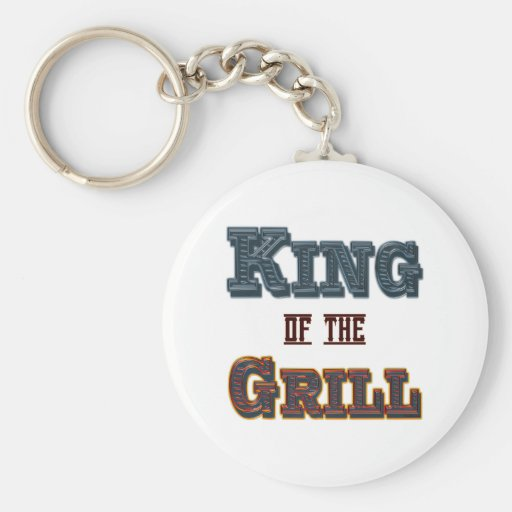Based on the design elements and color choices used in the text on the keychain, what type of event or product could this keychain be associated with, and why might these specific colors and the phrase have been chosen to represent it? The keychain features the phrase 'KING OF THE GRILL', rendered in an eye-catching font with a blue and red to gold gradient color scheme. This design likely denotes an event or product related to barbecuing or outdoor cooking. The choice of 'KING' in blue signifies authority and reliability, suggesting that the owner takes pride in their grilling skills. The gradient from red to golden yellow in 'GRILL' is reminiscent of fire and heat, essential elements of grilling. The combination of these design elements portrays not just skill but also passion and energy, making it an ideal emblem for someone who considers themselves a master of the grill. Such a keychain could be popular as a gift at barbecue competitions, cooking events, or as a personal accessory that celebrates one's prowess at the barbecue. 